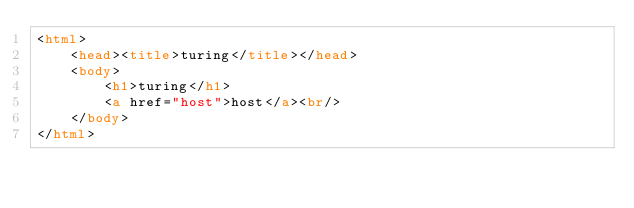<code> <loc_0><loc_0><loc_500><loc_500><_HTML_><html>
    <head><title>turing</title></head>
    <body>
        <h1>turing</h1>
        <a href="host">host</a><br/>
    </body>
</html>
</code> 